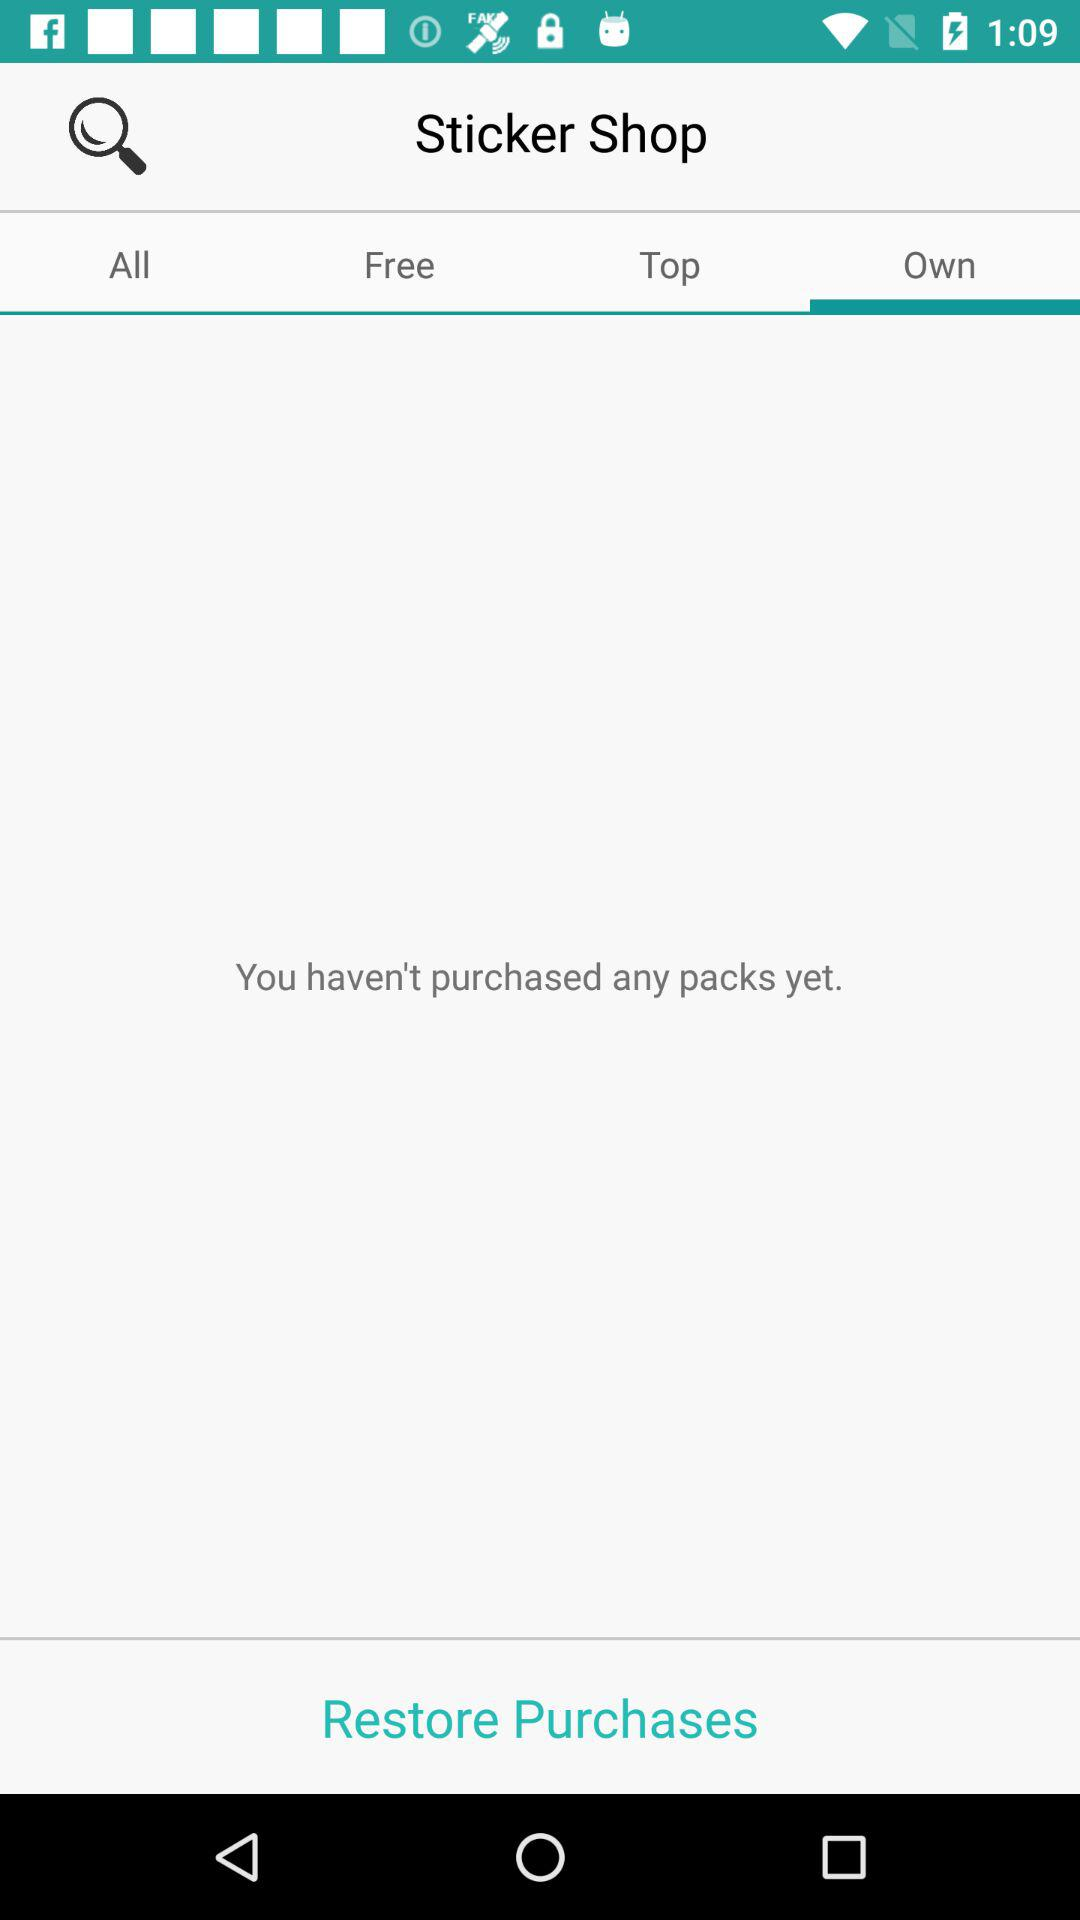How many packs have I purchased?
Answer the question using a single word or phrase. 0 